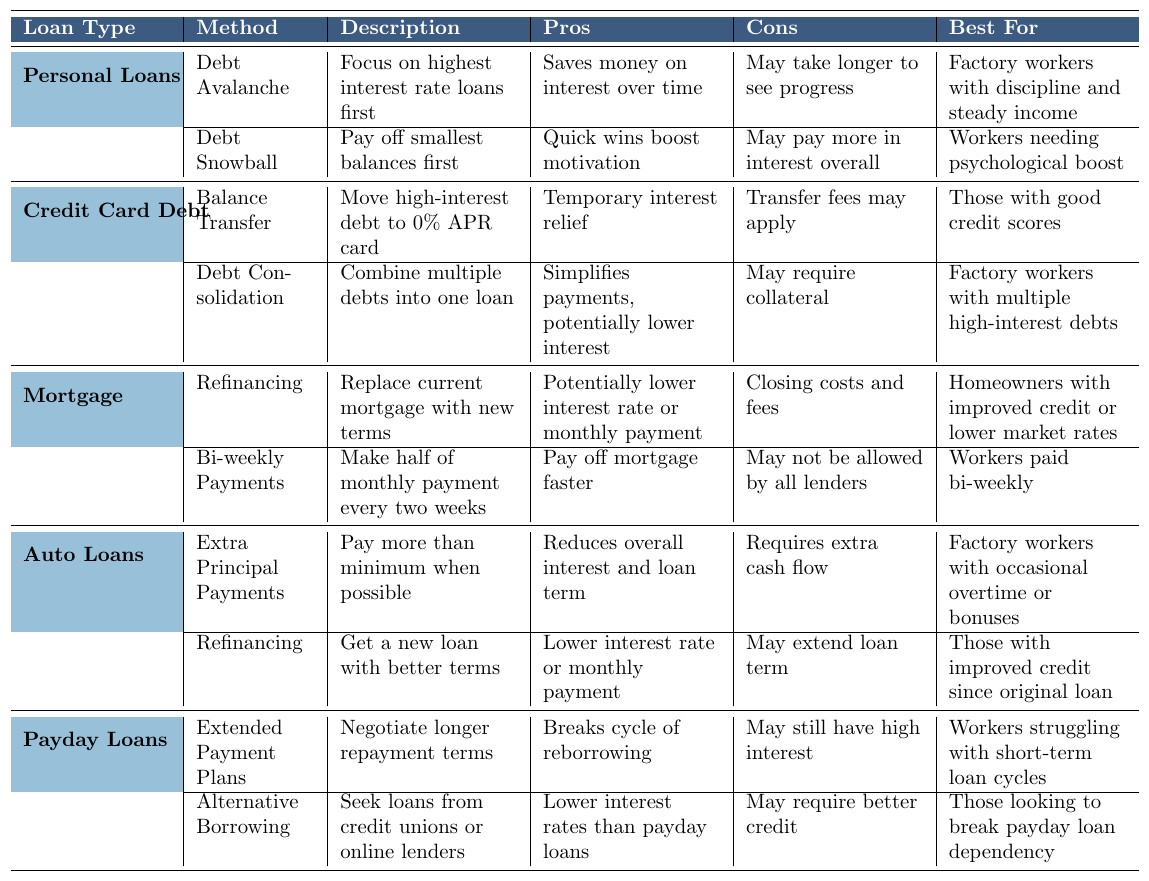What are the two debt repayment strategies listed for personal loans? The table shows two strategies for personal loans: Debt Avalanche and Debt Snowball.
Answer: Debt Avalanche and Debt Snowball Which repayment strategy is best for factory workers who need quick motivation? The table indicates that the Debt Snowball method is best for workers needing a psychological boost.
Answer: Debt Snowball Does the Balance Transfer strategy apply to all borrowers? The table specifies that the Balance Transfer method is best for those with good credit scores, indicating it does not apply to all borrowers.
Answer: No What is the main advantage of using the Debt Avalanche method? According to the table, the main advantage of the Debt Avalanche method is that it saves money on interest over time.
Answer: Saves money on interest How many strategies are listed for managing auto loans? The table shows that there are two strategies listed for auto loans: Extra Principal Payments and Refinancing.
Answer: Two strategies If a factory worker occasionally receives overtime pay, which repayment strategy might be beneficial for auto loans? The Extra Principal Payments strategy is suitable for factory workers with occasional overtime, as it allows them to pay more than the minimum when possible.
Answer: Extra Principal Payments True or False: The Debt Consolidation strategy is aimed at simplifying payments. The table states that Debt Consolidation combines multiple debts into one loan, simplifying payments, making this statement true.
Answer: True Which loan types offer a refinancing strategy? Reviewing the table, refinancing strategies are available for Mortgages and Auto Loans.
Answer: Mortgages and Auto Loans Which strategy for payday loans helps to negotiate longer repayment terms? The Extended Payment Plans strategy is shown in the table as a way to negotiate longer repayment terms for payday loans.
Answer: Extended Payment Plans What are the primary pros of the Bi-weekly Payments strategy for mortgages? The table outlines that Bi-weekly Payments can help in paying off the mortgage faster, which is its primary advantage.
Answer: Pay off mortgage faster What strategies would be suitable for workers struggling with short-term loan cycles? The table suggests that Extended Payment Plans and Alternative Borrowing are suitable strategies for workers facing issues with payday loans.
Answer: Extended Payment Plans and Alternative Borrowing 